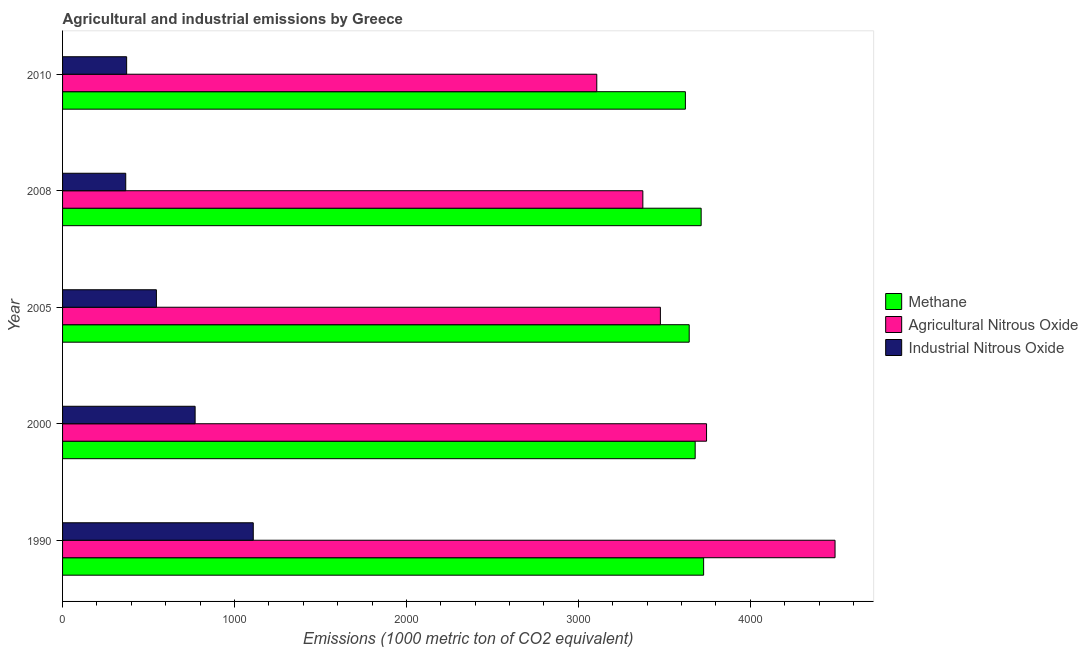Are the number of bars per tick equal to the number of legend labels?
Provide a short and direct response. Yes. Are the number of bars on each tick of the Y-axis equal?
Your answer should be very brief. Yes. How many bars are there on the 2nd tick from the top?
Give a very brief answer. 3. How many bars are there on the 3rd tick from the bottom?
Make the answer very short. 3. What is the amount of industrial nitrous oxide emissions in 2005?
Make the answer very short. 545.8. Across all years, what is the maximum amount of industrial nitrous oxide emissions?
Provide a short and direct response. 1109.1. Across all years, what is the minimum amount of methane emissions?
Keep it short and to the point. 3622.4. In which year was the amount of methane emissions maximum?
Ensure brevity in your answer.  1990. What is the total amount of agricultural nitrous oxide emissions in the graph?
Your answer should be compact. 1.82e+04. What is the difference between the amount of industrial nitrous oxide emissions in 1990 and that in 2000?
Give a very brief answer. 338.1. What is the difference between the amount of industrial nitrous oxide emissions in 2000 and the amount of agricultural nitrous oxide emissions in 2005?
Give a very brief answer. -2706. What is the average amount of methane emissions per year?
Keep it short and to the point. 3677.78. In the year 2000, what is the difference between the amount of methane emissions and amount of industrial nitrous oxide emissions?
Provide a short and direct response. 2908.3. In how many years, is the amount of methane emissions greater than 4200 metric ton?
Offer a terse response. 0. Is the difference between the amount of agricultural nitrous oxide emissions in 2000 and 2005 greater than the difference between the amount of methane emissions in 2000 and 2005?
Offer a terse response. Yes. What is the difference between the highest and the second highest amount of agricultural nitrous oxide emissions?
Make the answer very short. 747.3. What is the difference between the highest and the lowest amount of methane emissions?
Keep it short and to the point. 106.1. Is the sum of the amount of agricultural nitrous oxide emissions in 2005 and 2008 greater than the maximum amount of methane emissions across all years?
Provide a succinct answer. Yes. What does the 2nd bar from the top in 1990 represents?
Your answer should be very brief. Agricultural Nitrous Oxide. What does the 3rd bar from the bottom in 2005 represents?
Offer a terse response. Industrial Nitrous Oxide. How many bars are there?
Your answer should be compact. 15. How many years are there in the graph?
Offer a very short reply. 5. What is the difference between two consecutive major ticks on the X-axis?
Your answer should be very brief. 1000. Does the graph contain any zero values?
Provide a succinct answer. No. Does the graph contain grids?
Keep it short and to the point. No. Where does the legend appear in the graph?
Your answer should be compact. Center right. How many legend labels are there?
Offer a terse response. 3. What is the title of the graph?
Make the answer very short. Agricultural and industrial emissions by Greece. What is the label or title of the X-axis?
Your response must be concise. Emissions (1000 metric ton of CO2 equivalent). What is the label or title of the Y-axis?
Offer a terse response. Year. What is the Emissions (1000 metric ton of CO2 equivalent) of Methane in 1990?
Ensure brevity in your answer.  3728.5. What is the Emissions (1000 metric ton of CO2 equivalent) in Agricultural Nitrous Oxide in 1990?
Offer a terse response. 4492.8. What is the Emissions (1000 metric ton of CO2 equivalent) in Industrial Nitrous Oxide in 1990?
Keep it short and to the point. 1109.1. What is the Emissions (1000 metric ton of CO2 equivalent) of Methane in 2000?
Offer a very short reply. 3679.3. What is the Emissions (1000 metric ton of CO2 equivalent) of Agricultural Nitrous Oxide in 2000?
Give a very brief answer. 3745.5. What is the Emissions (1000 metric ton of CO2 equivalent) of Industrial Nitrous Oxide in 2000?
Ensure brevity in your answer.  771. What is the Emissions (1000 metric ton of CO2 equivalent) of Methane in 2005?
Make the answer very short. 3644.6. What is the Emissions (1000 metric ton of CO2 equivalent) of Agricultural Nitrous Oxide in 2005?
Provide a succinct answer. 3477. What is the Emissions (1000 metric ton of CO2 equivalent) of Industrial Nitrous Oxide in 2005?
Provide a short and direct response. 545.8. What is the Emissions (1000 metric ton of CO2 equivalent) in Methane in 2008?
Your answer should be very brief. 3714.1. What is the Emissions (1000 metric ton of CO2 equivalent) in Agricultural Nitrous Oxide in 2008?
Ensure brevity in your answer.  3375. What is the Emissions (1000 metric ton of CO2 equivalent) in Industrial Nitrous Oxide in 2008?
Give a very brief answer. 367.4. What is the Emissions (1000 metric ton of CO2 equivalent) in Methane in 2010?
Make the answer very short. 3622.4. What is the Emissions (1000 metric ton of CO2 equivalent) in Agricultural Nitrous Oxide in 2010?
Keep it short and to the point. 3107.1. What is the Emissions (1000 metric ton of CO2 equivalent) of Industrial Nitrous Oxide in 2010?
Your response must be concise. 372.7. Across all years, what is the maximum Emissions (1000 metric ton of CO2 equivalent) of Methane?
Provide a short and direct response. 3728.5. Across all years, what is the maximum Emissions (1000 metric ton of CO2 equivalent) in Agricultural Nitrous Oxide?
Provide a short and direct response. 4492.8. Across all years, what is the maximum Emissions (1000 metric ton of CO2 equivalent) in Industrial Nitrous Oxide?
Offer a very short reply. 1109.1. Across all years, what is the minimum Emissions (1000 metric ton of CO2 equivalent) in Methane?
Offer a terse response. 3622.4. Across all years, what is the minimum Emissions (1000 metric ton of CO2 equivalent) in Agricultural Nitrous Oxide?
Your response must be concise. 3107.1. Across all years, what is the minimum Emissions (1000 metric ton of CO2 equivalent) in Industrial Nitrous Oxide?
Make the answer very short. 367.4. What is the total Emissions (1000 metric ton of CO2 equivalent) in Methane in the graph?
Ensure brevity in your answer.  1.84e+04. What is the total Emissions (1000 metric ton of CO2 equivalent) of Agricultural Nitrous Oxide in the graph?
Provide a succinct answer. 1.82e+04. What is the total Emissions (1000 metric ton of CO2 equivalent) in Industrial Nitrous Oxide in the graph?
Keep it short and to the point. 3166. What is the difference between the Emissions (1000 metric ton of CO2 equivalent) of Methane in 1990 and that in 2000?
Make the answer very short. 49.2. What is the difference between the Emissions (1000 metric ton of CO2 equivalent) in Agricultural Nitrous Oxide in 1990 and that in 2000?
Make the answer very short. 747.3. What is the difference between the Emissions (1000 metric ton of CO2 equivalent) of Industrial Nitrous Oxide in 1990 and that in 2000?
Offer a very short reply. 338.1. What is the difference between the Emissions (1000 metric ton of CO2 equivalent) of Methane in 1990 and that in 2005?
Ensure brevity in your answer.  83.9. What is the difference between the Emissions (1000 metric ton of CO2 equivalent) of Agricultural Nitrous Oxide in 1990 and that in 2005?
Your response must be concise. 1015.8. What is the difference between the Emissions (1000 metric ton of CO2 equivalent) in Industrial Nitrous Oxide in 1990 and that in 2005?
Your response must be concise. 563.3. What is the difference between the Emissions (1000 metric ton of CO2 equivalent) of Agricultural Nitrous Oxide in 1990 and that in 2008?
Your answer should be very brief. 1117.8. What is the difference between the Emissions (1000 metric ton of CO2 equivalent) in Industrial Nitrous Oxide in 1990 and that in 2008?
Your response must be concise. 741.7. What is the difference between the Emissions (1000 metric ton of CO2 equivalent) in Methane in 1990 and that in 2010?
Provide a short and direct response. 106.1. What is the difference between the Emissions (1000 metric ton of CO2 equivalent) in Agricultural Nitrous Oxide in 1990 and that in 2010?
Offer a terse response. 1385.7. What is the difference between the Emissions (1000 metric ton of CO2 equivalent) of Industrial Nitrous Oxide in 1990 and that in 2010?
Provide a short and direct response. 736.4. What is the difference between the Emissions (1000 metric ton of CO2 equivalent) in Methane in 2000 and that in 2005?
Your answer should be very brief. 34.7. What is the difference between the Emissions (1000 metric ton of CO2 equivalent) of Agricultural Nitrous Oxide in 2000 and that in 2005?
Keep it short and to the point. 268.5. What is the difference between the Emissions (1000 metric ton of CO2 equivalent) in Industrial Nitrous Oxide in 2000 and that in 2005?
Keep it short and to the point. 225.2. What is the difference between the Emissions (1000 metric ton of CO2 equivalent) of Methane in 2000 and that in 2008?
Your answer should be very brief. -34.8. What is the difference between the Emissions (1000 metric ton of CO2 equivalent) of Agricultural Nitrous Oxide in 2000 and that in 2008?
Your answer should be compact. 370.5. What is the difference between the Emissions (1000 metric ton of CO2 equivalent) of Industrial Nitrous Oxide in 2000 and that in 2008?
Ensure brevity in your answer.  403.6. What is the difference between the Emissions (1000 metric ton of CO2 equivalent) in Methane in 2000 and that in 2010?
Offer a terse response. 56.9. What is the difference between the Emissions (1000 metric ton of CO2 equivalent) in Agricultural Nitrous Oxide in 2000 and that in 2010?
Give a very brief answer. 638.4. What is the difference between the Emissions (1000 metric ton of CO2 equivalent) in Industrial Nitrous Oxide in 2000 and that in 2010?
Offer a very short reply. 398.3. What is the difference between the Emissions (1000 metric ton of CO2 equivalent) of Methane in 2005 and that in 2008?
Provide a short and direct response. -69.5. What is the difference between the Emissions (1000 metric ton of CO2 equivalent) in Agricultural Nitrous Oxide in 2005 and that in 2008?
Your answer should be compact. 102. What is the difference between the Emissions (1000 metric ton of CO2 equivalent) of Industrial Nitrous Oxide in 2005 and that in 2008?
Offer a terse response. 178.4. What is the difference between the Emissions (1000 metric ton of CO2 equivalent) of Methane in 2005 and that in 2010?
Give a very brief answer. 22.2. What is the difference between the Emissions (1000 metric ton of CO2 equivalent) in Agricultural Nitrous Oxide in 2005 and that in 2010?
Offer a very short reply. 369.9. What is the difference between the Emissions (1000 metric ton of CO2 equivalent) in Industrial Nitrous Oxide in 2005 and that in 2010?
Your answer should be very brief. 173.1. What is the difference between the Emissions (1000 metric ton of CO2 equivalent) of Methane in 2008 and that in 2010?
Make the answer very short. 91.7. What is the difference between the Emissions (1000 metric ton of CO2 equivalent) in Agricultural Nitrous Oxide in 2008 and that in 2010?
Your answer should be compact. 267.9. What is the difference between the Emissions (1000 metric ton of CO2 equivalent) of Methane in 1990 and the Emissions (1000 metric ton of CO2 equivalent) of Agricultural Nitrous Oxide in 2000?
Your answer should be compact. -17. What is the difference between the Emissions (1000 metric ton of CO2 equivalent) in Methane in 1990 and the Emissions (1000 metric ton of CO2 equivalent) in Industrial Nitrous Oxide in 2000?
Give a very brief answer. 2957.5. What is the difference between the Emissions (1000 metric ton of CO2 equivalent) in Agricultural Nitrous Oxide in 1990 and the Emissions (1000 metric ton of CO2 equivalent) in Industrial Nitrous Oxide in 2000?
Provide a succinct answer. 3721.8. What is the difference between the Emissions (1000 metric ton of CO2 equivalent) in Methane in 1990 and the Emissions (1000 metric ton of CO2 equivalent) in Agricultural Nitrous Oxide in 2005?
Keep it short and to the point. 251.5. What is the difference between the Emissions (1000 metric ton of CO2 equivalent) in Methane in 1990 and the Emissions (1000 metric ton of CO2 equivalent) in Industrial Nitrous Oxide in 2005?
Keep it short and to the point. 3182.7. What is the difference between the Emissions (1000 metric ton of CO2 equivalent) in Agricultural Nitrous Oxide in 1990 and the Emissions (1000 metric ton of CO2 equivalent) in Industrial Nitrous Oxide in 2005?
Provide a succinct answer. 3947. What is the difference between the Emissions (1000 metric ton of CO2 equivalent) of Methane in 1990 and the Emissions (1000 metric ton of CO2 equivalent) of Agricultural Nitrous Oxide in 2008?
Your response must be concise. 353.5. What is the difference between the Emissions (1000 metric ton of CO2 equivalent) in Methane in 1990 and the Emissions (1000 metric ton of CO2 equivalent) in Industrial Nitrous Oxide in 2008?
Give a very brief answer. 3361.1. What is the difference between the Emissions (1000 metric ton of CO2 equivalent) of Agricultural Nitrous Oxide in 1990 and the Emissions (1000 metric ton of CO2 equivalent) of Industrial Nitrous Oxide in 2008?
Keep it short and to the point. 4125.4. What is the difference between the Emissions (1000 metric ton of CO2 equivalent) of Methane in 1990 and the Emissions (1000 metric ton of CO2 equivalent) of Agricultural Nitrous Oxide in 2010?
Your answer should be compact. 621.4. What is the difference between the Emissions (1000 metric ton of CO2 equivalent) of Methane in 1990 and the Emissions (1000 metric ton of CO2 equivalent) of Industrial Nitrous Oxide in 2010?
Your answer should be very brief. 3355.8. What is the difference between the Emissions (1000 metric ton of CO2 equivalent) of Agricultural Nitrous Oxide in 1990 and the Emissions (1000 metric ton of CO2 equivalent) of Industrial Nitrous Oxide in 2010?
Ensure brevity in your answer.  4120.1. What is the difference between the Emissions (1000 metric ton of CO2 equivalent) in Methane in 2000 and the Emissions (1000 metric ton of CO2 equivalent) in Agricultural Nitrous Oxide in 2005?
Offer a very short reply. 202.3. What is the difference between the Emissions (1000 metric ton of CO2 equivalent) in Methane in 2000 and the Emissions (1000 metric ton of CO2 equivalent) in Industrial Nitrous Oxide in 2005?
Keep it short and to the point. 3133.5. What is the difference between the Emissions (1000 metric ton of CO2 equivalent) in Agricultural Nitrous Oxide in 2000 and the Emissions (1000 metric ton of CO2 equivalent) in Industrial Nitrous Oxide in 2005?
Your response must be concise. 3199.7. What is the difference between the Emissions (1000 metric ton of CO2 equivalent) in Methane in 2000 and the Emissions (1000 metric ton of CO2 equivalent) in Agricultural Nitrous Oxide in 2008?
Ensure brevity in your answer.  304.3. What is the difference between the Emissions (1000 metric ton of CO2 equivalent) of Methane in 2000 and the Emissions (1000 metric ton of CO2 equivalent) of Industrial Nitrous Oxide in 2008?
Give a very brief answer. 3311.9. What is the difference between the Emissions (1000 metric ton of CO2 equivalent) in Agricultural Nitrous Oxide in 2000 and the Emissions (1000 metric ton of CO2 equivalent) in Industrial Nitrous Oxide in 2008?
Give a very brief answer. 3378.1. What is the difference between the Emissions (1000 metric ton of CO2 equivalent) of Methane in 2000 and the Emissions (1000 metric ton of CO2 equivalent) of Agricultural Nitrous Oxide in 2010?
Give a very brief answer. 572.2. What is the difference between the Emissions (1000 metric ton of CO2 equivalent) of Methane in 2000 and the Emissions (1000 metric ton of CO2 equivalent) of Industrial Nitrous Oxide in 2010?
Provide a succinct answer. 3306.6. What is the difference between the Emissions (1000 metric ton of CO2 equivalent) of Agricultural Nitrous Oxide in 2000 and the Emissions (1000 metric ton of CO2 equivalent) of Industrial Nitrous Oxide in 2010?
Make the answer very short. 3372.8. What is the difference between the Emissions (1000 metric ton of CO2 equivalent) in Methane in 2005 and the Emissions (1000 metric ton of CO2 equivalent) in Agricultural Nitrous Oxide in 2008?
Provide a succinct answer. 269.6. What is the difference between the Emissions (1000 metric ton of CO2 equivalent) in Methane in 2005 and the Emissions (1000 metric ton of CO2 equivalent) in Industrial Nitrous Oxide in 2008?
Offer a terse response. 3277.2. What is the difference between the Emissions (1000 metric ton of CO2 equivalent) in Agricultural Nitrous Oxide in 2005 and the Emissions (1000 metric ton of CO2 equivalent) in Industrial Nitrous Oxide in 2008?
Offer a terse response. 3109.6. What is the difference between the Emissions (1000 metric ton of CO2 equivalent) in Methane in 2005 and the Emissions (1000 metric ton of CO2 equivalent) in Agricultural Nitrous Oxide in 2010?
Provide a succinct answer. 537.5. What is the difference between the Emissions (1000 metric ton of CO2 equivalent) of Methane in 2005 and the Emissions (1000 metric ton of CO2 equivalent) of Industrial Nitrous Oxide in 2010?
Offer a very short reply. 3271.9. What is the difference between the Emissions (1000 metric ton of CO2 equivalent) of Agricultural Nitrous Oxide in 2005 and the Emissions (1000 metric ton of CO2 equivalent) of Industrial Nitrous Oxide in 2010?
Keep it short and to the point. 3104.3. What is the difference between the Emissions (1000 metric ton of CO2 equivalent) in Methane in 2008 and the Emissions (1000 metric ton of CO2 equivalent) in Agricultural Nitrous Oxide in 2010?
Provide a succinct answer. 607. What is the difference between the Emissions (1000 metric ton of CO2 equivalent) of Methane in 2008 and the Emissions (1000 metric ton of CO2 equivalent) of Industrial Nitrous Oxide in 2010?
Your response must be concise. 3341.4. What is the difference between the Emissions (1000 metric ton of CO2 equivalent) in Agricultural Nitrous Oxide in 2008 and the Emissions (1000 metric ton of CO2 equivalent) in Industrial Nitrous Oxide in 2010?
Provide a succinct answer. 3002.3. What is the average Emissions (1000 metric ton of CO2 equivalent) of Methane per year?
Your response must be concise. 3677.78. What is the average Emissions (1000 metric ton of CO2 equivalent) in Agricultural Nitrous Oxide per year?
Offer a terse response. 3639.48. What is the average Emissions (1000 metric ton of CO2 equivalent) of Industrial Nitrous Oxide per year?
Offer a terse response. 633.2. In the year 1990, what is the difference between the Emissions (1000 metric ton of CO2 equivalent) in Methane and Emissions (1000 metric ton of CO2 equivalent) in Agricultural Nitrous Oxide?
Make the answer very short. -764.3. In the year 1990, what is the difference between the Emissions (1000 metric ton of CO2 equivalent) of Methane and Emissions (1000 metric ton of CO2 equivalent) of Industrial Nitrous Oxide?
Provide a succinct answer. 2619.4. In the year 1990, what is the difference between the Emissions (1000 metric ton of CO2 equivalent) in Agricultural Nitrous Oxide and Emissions (1000 metric ton of CO2 equivalent) in Industrial Nitrous Oxide?
Offer a terse response. 3383.7. In the year 2000, what is the difference between the Emissions (1000 metric ton of CO2 equivalent) of Methane and Emissions (1000 metric ton of CO2 equivalent) of Agricultural Nitrous Oxide?
Ensure brevity in your answer.  -66.2. In the year 2000, what is the difference between the Emissions (1000 metric ton of CO2 equivalent) of Methane and Emissions (1000 metric ton of CO2 equivalent) of Industrial Nitrous Oxide?
Keep it short and to the point. 2908.3. In the year 2000, what is the difference between the Emissions (1000 metric ton of CO2 equivalent) in Agricultural Nitrous Oxide and Emissions (1000 metric ton of CO2 equivalent) in Industrial Nitrous Oxide?
Your answer should be compact. 2974.5. In the year 2005, what is the difference between the Emissions (1000 metric ton of CO2 equivalent) of Methane and Emissions (1000 metric ton of CO2 equivalent) of Agricultural Nitrous Oxide?
Ensure brevity in your answer.  167.6. In the year 2005, what is the difference between the Emissions (1000 metric ton of CO2 equivalent) of Methane and Emissions (1000 metric ton of CO2 equivalent) of Industrial Nitrous Oxide?
Keep it short and to the point. 3098.8. In the year 2005, what is the difference between the Emissions (1000 metric ton of CO2 equivalent) in Agricultural Nitrous Oxide and Emissions (1000 metric ton of CO2 equivalent) in Industrial Nitrous Oxide?
Provide a short and direct response. 2931.2. In the year 2008, what is the difference between the Emissions (1000 metric ton of CO2 equivalent) in Methane and Emissions (1000 metric ton of CO2 equivalent) in Agricultural Nitrous Oxide?
Provide a short and direct response. 339.1. In the year 2008, what is the difference between the Emissions (1000 metric ton of CO2 equivalent) of Methane and Emissions (1000 metric ton of CO2 equivalent) of Industrial Nitrous Oxide?
Keep it short and to the point. 3346.7. In the year 2008, what is the difference between the Emissions (1000 metric ton of CO2 equivalent) in Agricultural Nitrous Oxide and Emissions (1000 metric ton of CO2 equivalent) in Industrial Nitrous Oxide?
Give a very brief answer. 3007.6. In the year 2010, what is the difference between the Emissions (1000 metric ton of CO2 equivalent) in Methane and Emissions (1000 metric ton of CO2 equivalent) in Agricultural Nitrous Oxide?
Give a very brief answer. 515.3. In the year 2010, what is the difference between the Emissions (1000 metric ton of CO2 equivalent) in Methane and Emissions (1000 metric ton of CO2 equivalent) in Industrial Nitrous Oxide?
Ensure brevity in your answer.  3249.7. In the year 2010, what is the difference between the Emissions (1000 metric ton of CO2 equivalent) in Agricultural Nitrous Oxide and Emissions (1000 metric ton of CO2 equivalent) in Industrial Nitrous Oxide?
Provide a short and direct response. 2734.4. What is the ratio of the Emissions (1000 metric ton of CO2 equivalent) in Methane in 1990 to that in 2000?
Ensure brevity in your answer.  1.01. What is the ratio of the Emissions (1000 metric ton of CO2 equivalent) in Agricultural Nitrous Oxide in 1990 to that in 2000?
Offer a terse response. 1.2. What is the ratio of the Emissions (1000 metric ton of CO2 equivalent) of Industrial Nitrous Oxide in 1990 to that in 2000?
Give a very brief answer. 1.44. What is the ratio of the Emissions (1000 metric ton of CO2 equivalent) of Agricultural Nitrous Oxide in 1990 to that in 2005?
Provide a succinct answer. 1.29. What is the ratio of the Emissions (1000 metric ton of CO2 equivalent) in Industrial Nitrous Oxide in 1990 to that in 2005?
Ensure brevity in your answer.  2.03. What is the ratio of the Emissions (1000 metric ton of CO2 equivalent) in Methane in 1990 to that in 2008?
Your response must be concise. 1. What is the ratio of the Emissions (1000 metric ton of CO2 equivalent) of Agricultural Nitrous Oxide in 1990 to that in 2008?
Offer a terse response. 1.33. What is the ratio of the Emissions (1000 metric ton of CO2 equivalent) in Industrial Nitrous Oxide in 1990 to that in 2008?
Offer a very short reply. 3.02. What is the ratio of the Emissions (1000 metric ton of CO2 equivalent) of Methane in 1990 to that in 2010?
Your response must be concise. 1.03. What is the ratio of the Emissions (1000 metric ton of CO2 equivalent) in Agricultural Nitrous Oxide in 1990 to that in 2010?
Offer a very short reply. 1.45. What is the ratio of the Emissions (1000 metric ton of CO2 equivalent) of Industrial Nitrous Oxide in 1990 to that in 2010?
Your response must be concise. 2.98. What is the ratio of the Emissions (1000 metric ton of CO2 equivalent) of Methane in 2000 to that in 2005?
Keep it short and to the point. 1.01. What is the ratio of the Emissions (1000 metric ton of CO2 equivalent) in Agricultural Nitrous Oxide in 2000 to that in 2005?
Ensure brevity in your answer.  1.08. What is the ratio of the Emissions (1000 metric ton of CO2 equivalent) of Industrial Nitrous Oxide in 2000 to that in 2005?
Offer a very short reply. 1.41. What is the ratio of the Emissions (1000 metric ton of CO2 equivalent) of Methane in 2000 to that in 2008?
Give a very brief answer. 0.99. What is the ratio of the Emissions (1000 metric ton of CO2 equivalent) in Agricultural Nitrous Oxide in 2000 to that in 2008?
Provide a succinct answer. 1.11. What is the ratio of the Emissions (1000 metric ton of CO2 equivalent) of Industrial Nitrous Oxide in 2000 to that in 2008?
Offer a very short reply. 2.1. What is the ratio of the Emissions (1000 metric ton of CO2 equivalent) in Methane in 2000 to that in 2010?
Give a very brief answer. 1.02. What is the ratio of the Emissions (1000 metric ton of CO2 equivalent) in Agricultural Nitrous Oxide in 2000 to that in 2010?
Offer a very short reply. 1.21. What is the ratio of the Emissions (1000 metric ton of CO2 equivalent) of Industrial Nitrous Oxide in 2000 to that in 2010?
Your answer should be compact. 2.07. What is the ratio of the Emissions (1000 metric ton of CO2 equivalent) of Methane in 2005 to that in 2008?
Make the answer very short. 0.98. What is the ratio of the Emissions (1000 metric ton of CO2 equivalent) in Agricultural Nitrous Oxide in 2005 to that in 2008?
Offer a very short reply. 1.03. What is the ratio of the Emissions (1000 metric ton of CO2 equivalent) in Industrial Nitrous Oxide in 2005 to that in 2008?
Provide a short and direct response. 1.49. What is the ratio of the Emissions (1000 metric ton of CO2 equivalent) in Methane in 2005 to that in 2010?
Give a very brief answer. 1.01. What is the ratio of the Emissions (1000 metric ton of CO2 equivalent) in Agricultural Nitrous Oxide in 2005 to that in 2010?
Offer a terse response. 1.12. What is the ratio of the Emissions (1000 metric ton of CO2 equivalent) in Industrial Nitrous Oxide in 2005 to that in 2010?
Provide a succinct answer. 1.46. What is the ratio of the Emissions (1000 metric ton of CO2 equivalent) in Methane in 2008 to that in 2010?
Make the answer very short. 1.03. What is the ratio of the Emissions (1000 metric ton of CO2 equivalent) of Agricultural Nitrous Oxide in 2008 to that in 2010?
Your answer should be very brief. 1.09. What is the ratio of the Emissions (1000 metric ton of CO2 equivalent) in Industrial Nitrous Oxide in 2008 to that in 2010?
Your response must be concise. 0.99. What is the difference between the highest and the second highest Emissions (1000 metric ton of CO2 equivalent) of Agricultural Nitrous Oxide?
Keep it short and to the point. 747.3. What is the difference between the highest and the second highest Emissions (1000 metric ton of CO2 equivalent) of Industrial Nitrous Oxide?
Provide a succinct answer. 338.1. What is the difference between the highest and the lowest Emissions (1000 metric ton of CO2 equivalent) in Methane?
Your response must be concise. 106.1. What is the difference between the highest and the lowest Emissions (1000 metric ton of CO2 equivalent) of Agricultural Nitrous Oxide?
Offer a very short reply. 1385.7. What is the difference between the highest and the lowest Emissions (1000 metric ton of CO2 equivalent) of Industrial Nitrous Oxide?
Offer a very short reply. 741.7. 